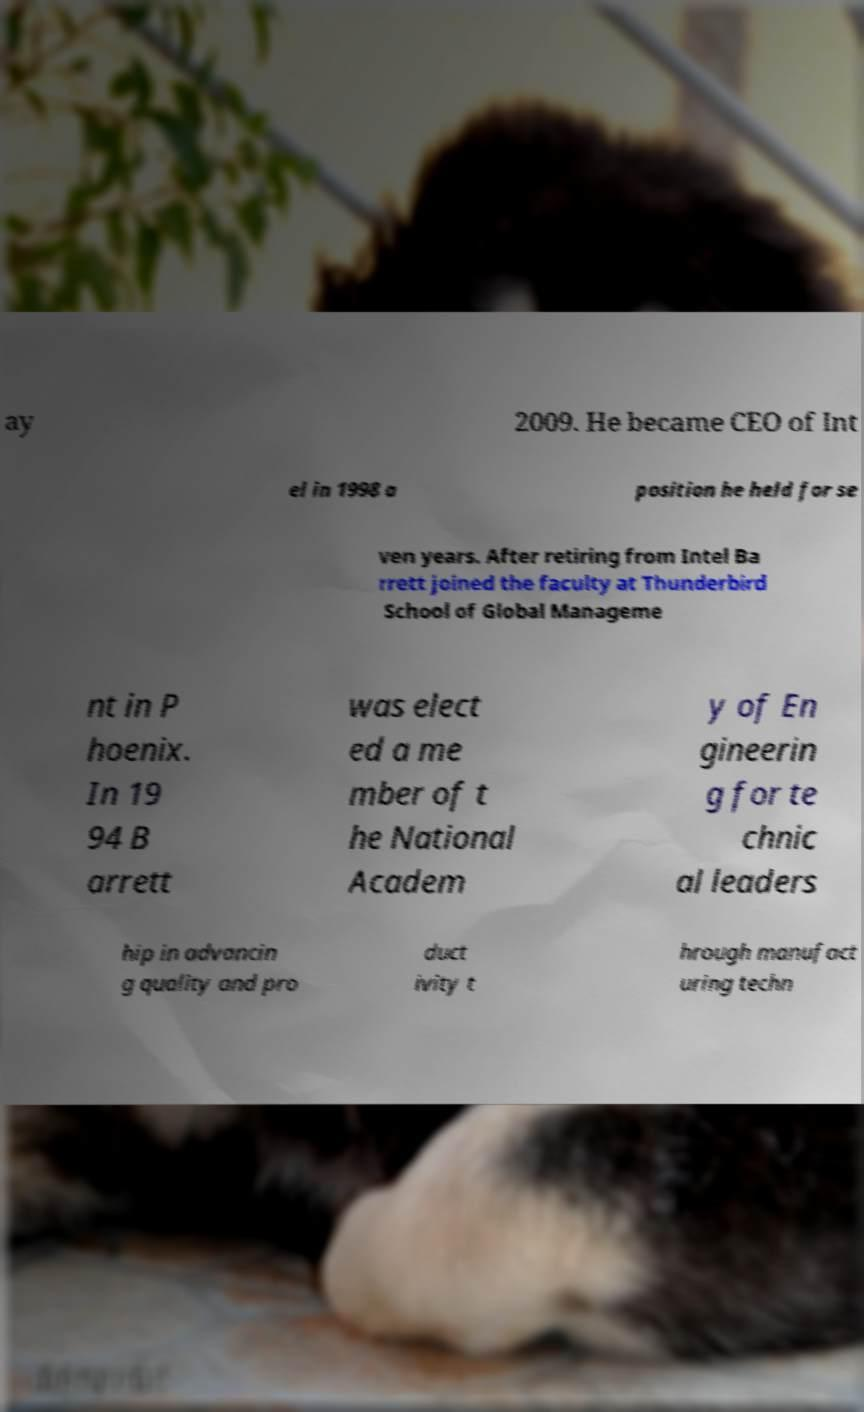Can you accurately transcribe the text from the provided image for me? ay 2009. He became CEO of Int el in 1998 a position he held for se ven years. After retiring from Intel Ba rrett joined the faculty at Thunderbird School of Global Manageme nt in P hoenix. In 19 94 B arrett was elect ed a me mber of t he National Academ y of En gineerin g for te chnic al leaders hip in advancin g quality and pro duct ivity t hrough manufact uring techn 